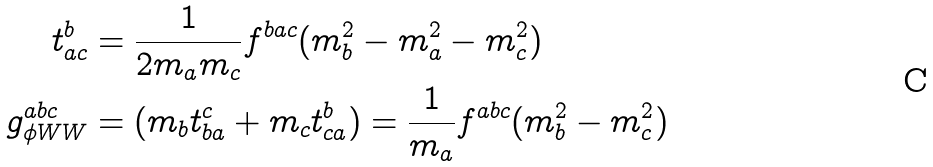<formula> <loc_0><loc_0><loc_500><loc_500>t ^ { b } _ { a c } & = \frac { 1 } { 2 m _ { a } m _ { c } } f ^ { b a c } ( m _ { b } ^ { 2 } - m _ { a } ^ { 2 } - m _ { c } ^ { 2 } ) \\ g _ { \phi W W } ^ { a b c } & = ( m _ { b } t ^ { c } _ { b a } + m _ { c } t ^ { b } _ { c a } ) = \frac { 1 } { m _ { a } } f ^ { a b c } ( m _ { b } ^ { 2 } - m _ { c } ^ { 2 } )</formula> 